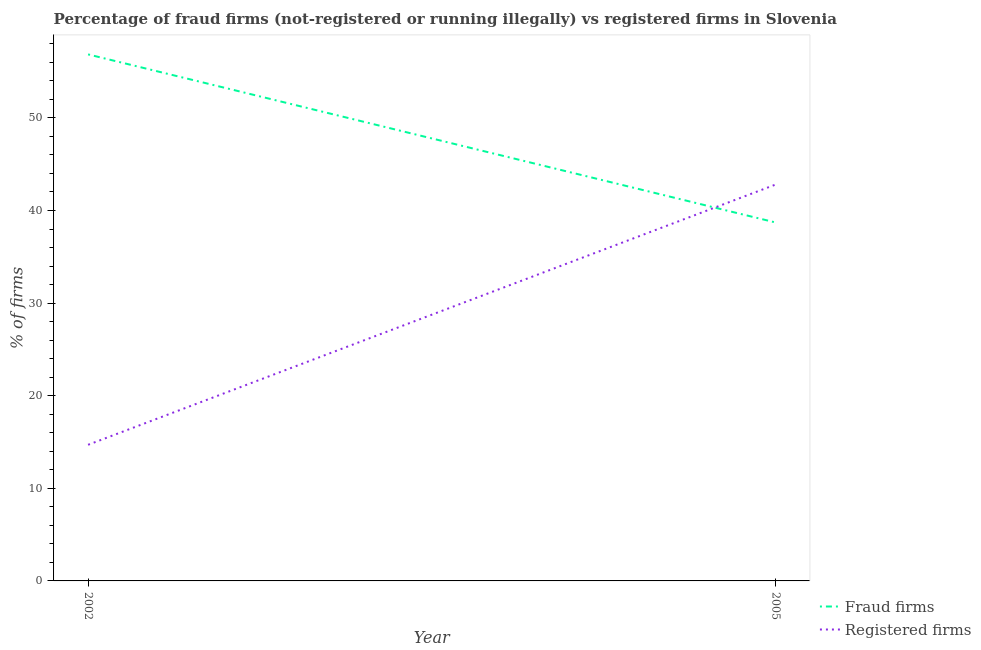What is the percentage of registered firms in 2005?
Keep it short and to the point. 42.8. Across all years, what is the maximum percentage of registered firms?
Your response must be concise. 42.8. Across all years, what is the minimum percentage of fraud firms?
Provide a short and direct response. 38.71. What is the total percentage of registered firms in the graph?
Your answer should be very brief. 57.5. What is the difference between the percentage of registered firms in 2002 and that in 2005?
Make the answer very short. -28.1. What is the difference between the percentage of registered firms in 2005 and the percentage of fraud firms in 2002?
Provide a short and direct response. -14.06. What is the average percentage of fraud firms per year?
Give a very brief answer. 47.78. In the year 2005, what is the difference between the percentage of fraud firms and percentage of registered firms?
Make the answer very short. -4.09. What is the ratio of the percentage of registered firms in 2002 to that in 2005?
Your answer should be very brief. 0.34. Is the percentage of fraud firms strictly greater than the percentage of registered firms over the years?
Ensure brevity in your answer.  No. How many lines are there?
Keep it short and to the point. 2. What is the title of the graph?
Provide a succinct answer. Percentage of fraud firms (not-registered or running illegally) vs registered firms in Slovenia. What is the label or title of the X-axis?
Keep it short and to the point. Year. What is the label or title of the Y-axis?
Make the answer very short. % of firms. What is the % of firms of Fraud firms in 2002?
Give a very brief answer. 56.86. What is the % of firms in Fraud firms in 2005?
Offer a terse response. 38.71. What is the % of firms in Registered firms in 2005?
Your answer should be compact. 42.8. Across all years, what is the maximum % of firms of Fraud firms?
Offer a very short reply. 56.86. Across all years, what is the maximum % of firms in Registered firms?
Your response must be concise. 42.8. Across all years, what is the minimum % of firms in Fraud firms?
Your answer should be very brief. 38.71. Across all years, what is the minimum % of firms of Registered firms?
Your answer should be very brief. 14.7. What is the total % of firms of Fraud firms in the graph?
Ensure brevity in your answer.  95.57. What is the total % of firms of Registered firms in the graph?
Give a very brief answer. 57.5. What is the difference between the % of firms of Fraud firms in 2002 and that in 2005?
Your response must be concise. 18.15. What is the difference between the % of firms of Registered firms in 2002 and that in 2005?
Give a very brief answer. -28.1. What is the difference between the % of firms of Fraud firms in 2002 and the % of firms of Registered firms in 2005?
Provide a short and direct response. 14.06. What is the average % of firms of Fraud firms per year?
Make the answer very short. 47.78. What is the average % of firms of Registered firms per year?
Your answer should be compact. 28.75. In the year 2002, what is the difference between the % of firms in Fraud firms and % of firms in Registered firms?
Your response must be concise. 42.16. In the year 2005, what is the difference between the % of firms in Fraud firms and % of firms in Registered firms?
Your answer should be very brief. -4.09. What is the ratio of the % of firms in Fraud firms in 2002 to that in 2005?
Offer a terse response. 1.47. What is the ratio of the % of firms in Registered firms in 2002 to that in 2005?
Keep it short and to the point. 0.34. What is the difference between the highest and the second highest % of firms of Fraud firms?
Your answer should be very brief. 18.15. What is the difference between the highest and the second highest % of firms in Registered firms?
Offer a terse response. 28.1. What is the difference between the highest and the lowest % of firms in Fraud firms?
Provide a short and direct response. 18.15. What is the difference between the highest and the lowest % of firms in Registered firms?
Your answer should be very brief. 28.1. 